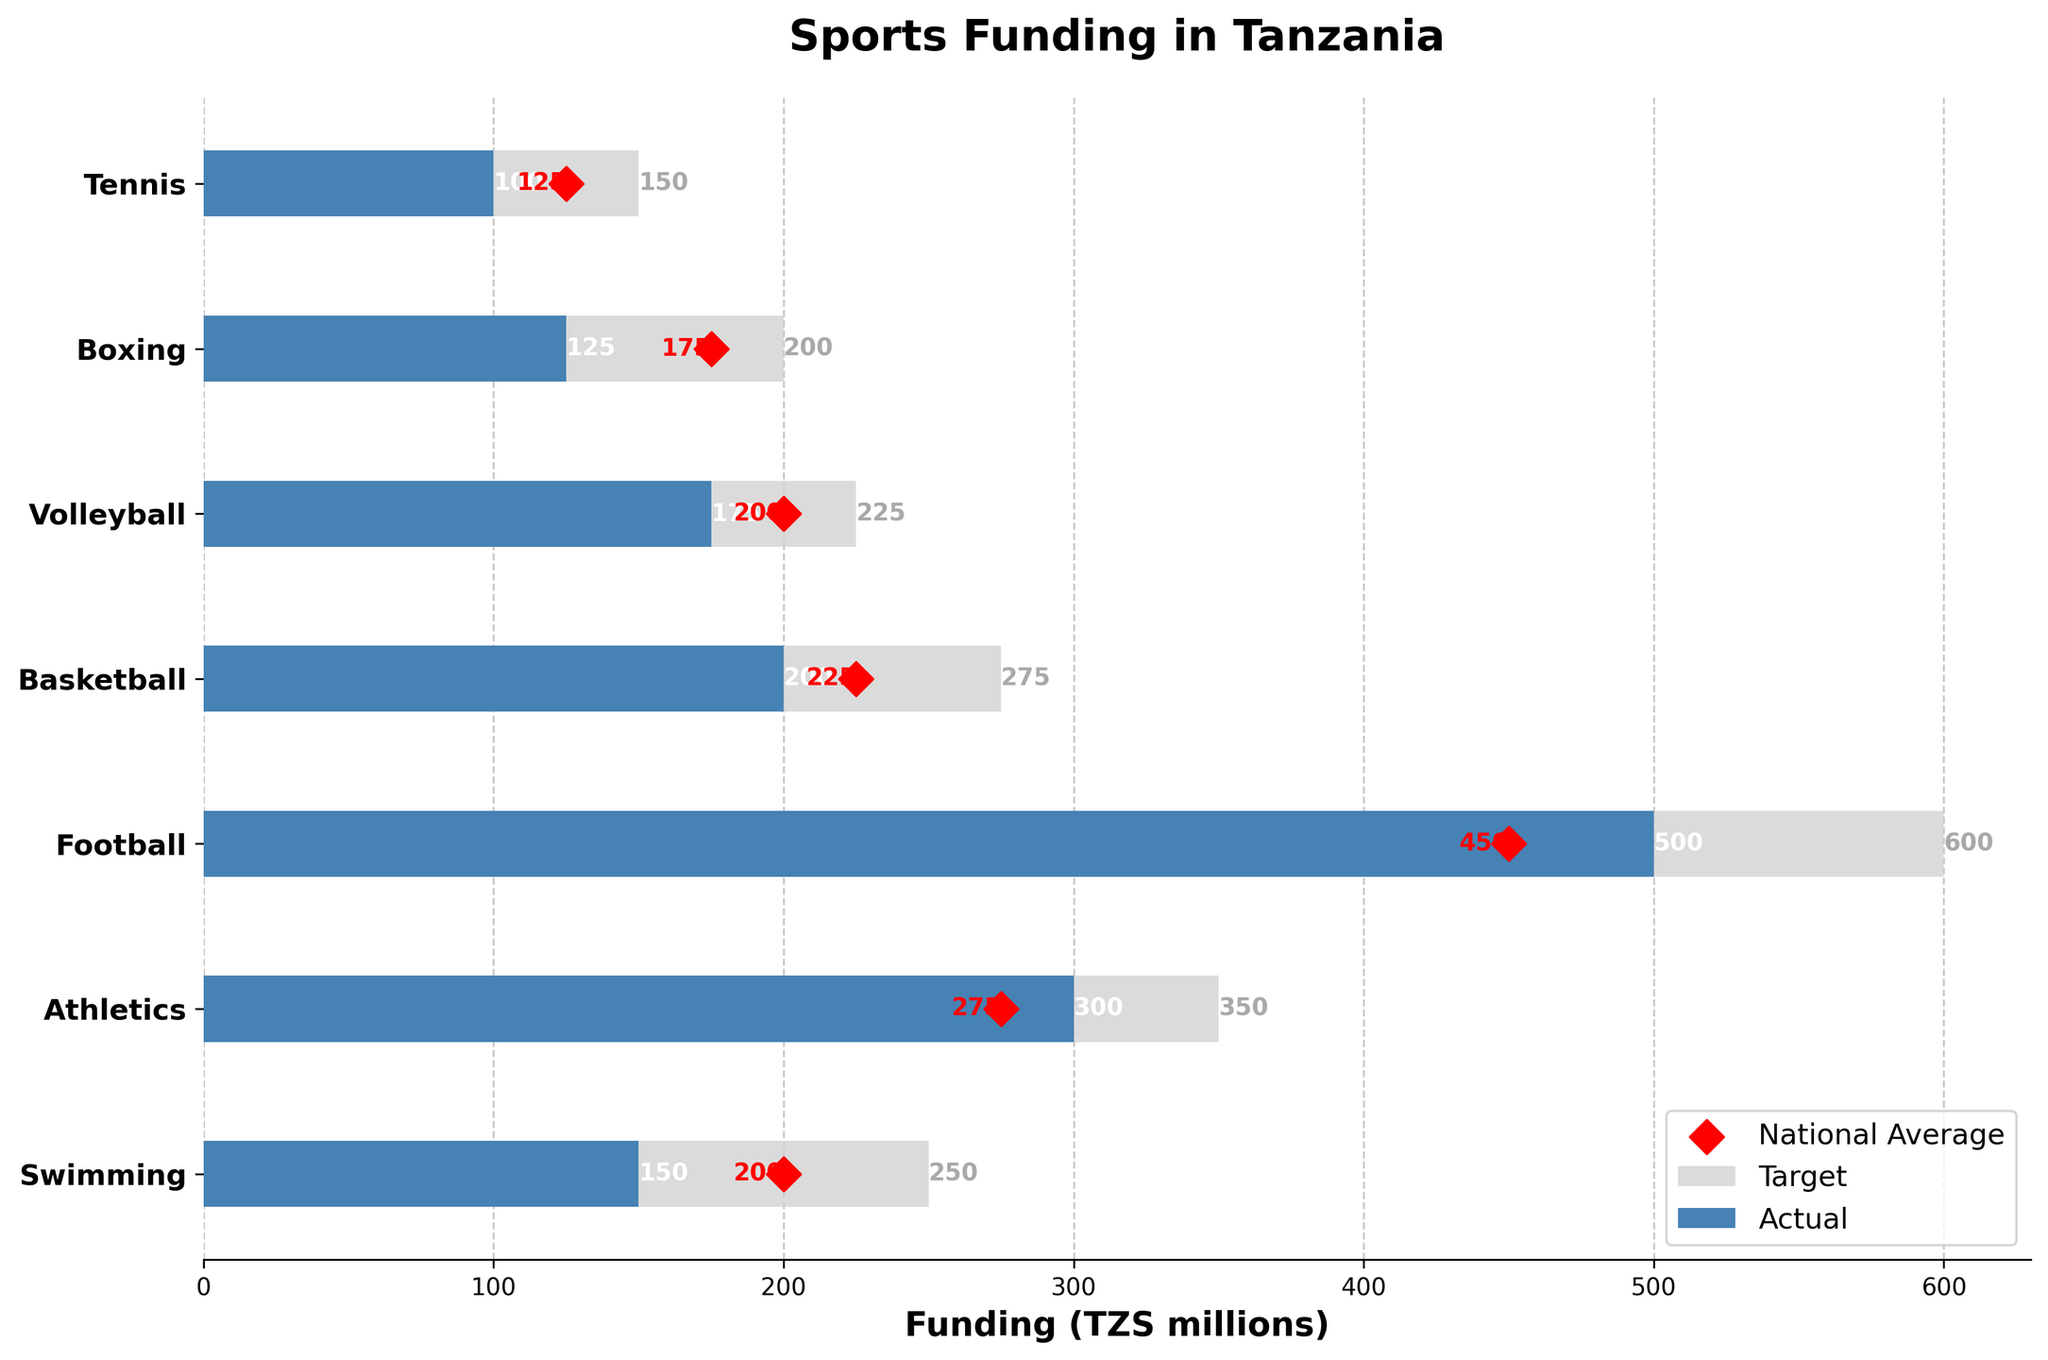What is the title of the figure? The title can be found at the top of the figure. It is clearly written in bold letters.
Answer: Sports Funding in Tanzania What is the actual funding amount for swimming? The actual funding amount is represented by the blue bar associated with swimming.
Answer: 150 million TZS Which sport received the highest target funding? To find the highest target funding, compare the grey bars of all sports. The sport with the longest grey bar is football.
Answer: Football How does the actual funding for swimming compare to its target funding? Compare the length of the blue bar (actual funding) with the grey bar (target funding) for swimming. The actual funding (150 million TZS) is less than the target funding (250 million TZS).
Answer: Less What is the difference between target and actual funding for volleyball? Calculate the difference by subtracting the actual funding from the target funding for volleyball: 225 - 175 = 50 million TZS.
Answer: 50 million TZS How does the national average funding for boxing compare to its actual funding? The national average is shown with a red diamond, and the actual funding is indicated by the blue bar for boxing. The national average (175 million TZS) is higher than the actual funding (125 million TZS).
Answer: Higher What is the combined actual funding for swimming and athletics? Add the actual funding figures for swimming and athletics: 150 + 300 = 450 million TZS.
Answer: 450 million TZS Which sport has the closest actual funding to the national average? Assess each sport to find where the blue bar's length closely matches the position of the red diamond. For basketball, both values are close: actual funding 200 million TZS and national average 225 million TZS.
Answer: Basketball Which sport has the largest funding discrepancy between actual and target amounts? Find the sport where the difference between the grey bar and blue bar is the largest. For football, the difference is 600 - 500 = 100 million TZS.
Answer: Football What can be inferred about the funding priorities for football in Tanzania? Football has the highest actual and target funding, which indicates a high priority for the sport's development in Tanzania.
Answer: High priority 